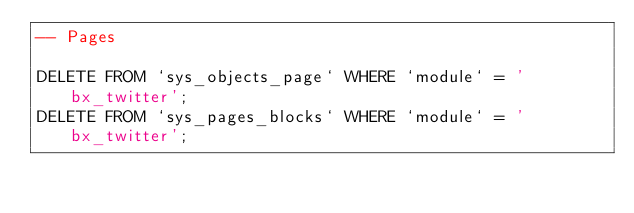<code> <loc_0><loc_0><loc_500><loc_500><_SQL_>-- Pages

DELETE FROM `sys_objects_page` WHERE `module` = 'bx_twitter';
DELETE FROM `sys_pages_blocks` WHERE `module` = 'bx_twitter';

</code> 